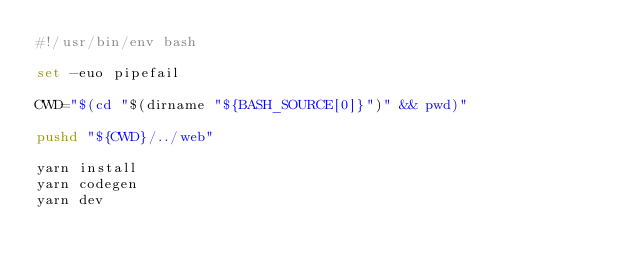Convert code to text. <code><loc_0><loc_0><loc_500><loc_500><_Bash_>#!/usr/bin/env bash

set -euo pipefail

CWD="$(cd "$(dirname "${BASH_SOURCE[0]}")" && pwd)"

pushd "${CWD}/../web"

yarn install
yarn codegen
yarn dev</code> 